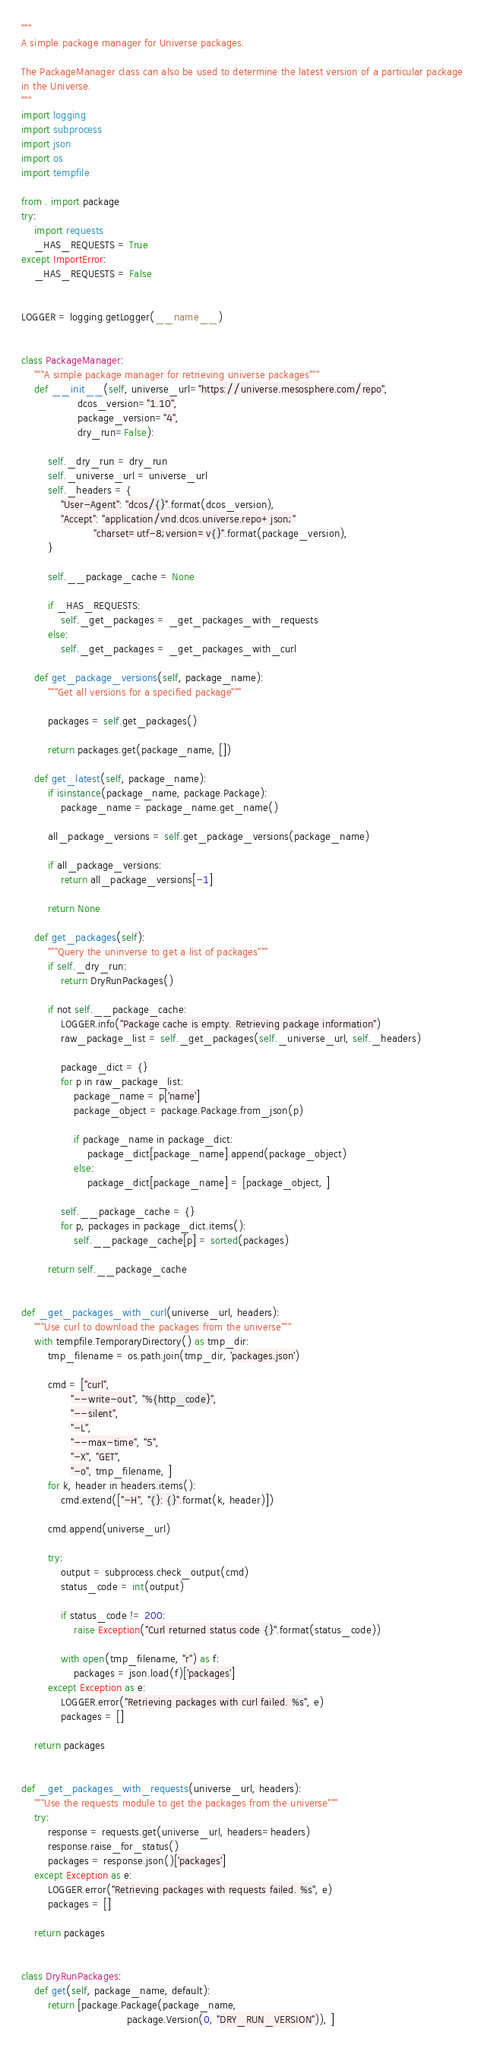<code> <loc_0><loc_0><loc_500><loc_500><_Python_>"""
A simple package manager for Universe packages.

The PackageManager class can also be used to determine the latest version of a particular package
in the Universe.
"""
import logging
import subprocess
import json
import os
import tempfile

from . import package
try:
    import requests
    _HAS_REQUESTS = True
except ImportError:
    _HAS_REQUESTS = False


LOGGER = logging.getLogger(__name__)


class PackageManager:
    """A simple package manager for retrieving universe packages"""
    def __init__(self, universe_url="https://universe.mesosphere.com/repo",
                 dcos_version="1.10",
                 package_version="4",
                 dry_run=False):

        self._dry_run = dry_run
        self._universe_url = universe_url
        self._headers = {
            "User-Agent": "dcos/{}".format(dcos_version),
            "Accept": "application/vnd.dcos.universe.repo+json;"
                      "charset=utf-8;version=v{}".format(package_version),
        }

        self.__package_cache = None

        if _HAS_REQUESTS:
            self._get_packages = _get_packages_with_requests
        else:
            self._get_packages = _get_packages_with_curl

    def get_package_versions(self, package_name):
        """Get all versions for a specified package"""

        packages = self.get_packages()

        return packages.get(package_name, [])

    def get_latest(self, package_name):
        if isinstance(package_name, package.Package):
            package_name = package_name.get_name()

        all_package_versions = self.get_package_versions(package_name)

        if all_package_versions:
            return all_package_versions[-1]

        return None

    def get_packages(self):
        """Query the uninverse to get a list of packages"""
        if self._dry_run:
            return DryRunPackages()

        if not self.__package_cache:
            LOGGER.info("Package cache is empty. Retrieving package information")
            raw_package_list = self._get_packages(self._universe_url, self._headers)

            package_dict = {}
            for p in raw_package_list:
                package_name = p['name']
                package_object = package.Package.from_json(p)

                if package_name in package_dict:
                    package_dict[package_name].append(package_object)
                else:
                    package_dict[package_name] = [package_object, ]

            self.__package_cache = {}
            for p, packages in package_dict.items():
                self.__package_cache[p] = sorted(packages)

        return self.__package_cache


def _get_packages_with_curl(universe_url, headers):
    """Use curl to download the packages from the universe"""
    with tempfile.TemporaryDirectory() as tmp_dir:
        tmp_filename = os.path.join(tmp_dir, 'packages.json')

        cmd = ["curl",
               "--write-out", "%{http_code}",
               "--silent",
               "-L",
               "--max-time", "5",
               "-X", "GET",
               "-o", tmp_filename, ]
        for k, header in headers.items():
            cmd.extend(["-H", "{}: {}".format(k, header)])

        cmd.append(universe_url)

        try:
            output = subprocess.check_output(cmd)
            status_code = int(output)

            if status_code != 200:
                raise Exception("Curl returned status code {}".format(status_code))

            with open(tmp_filename, "r") as f:
                packages = json.load(f)['packages']
        except Exception as e:
            LOGGER.error("Retrieving packages with curl failed. %s", e)
            packages = []

    return packages


def _get_packages_with_requests(universe_url, headers):
    """Use the requests module to get the packages from the universe"""
    try:
        response = requests.get(universe_url, headers=headers)
        response.raise_for_status()
        packages = response.json()['packages']
    except Exception as e:
        LOGGER.error("Retrieving packages with requests failed. %s", e)
        packages = []

    return packages


class DryRunPackages:
    def get(self, package_name, default):
        return [package.Package(package_name,
                                package.Version(0, "DRY_RUN_VERSION")), ]
</code> 